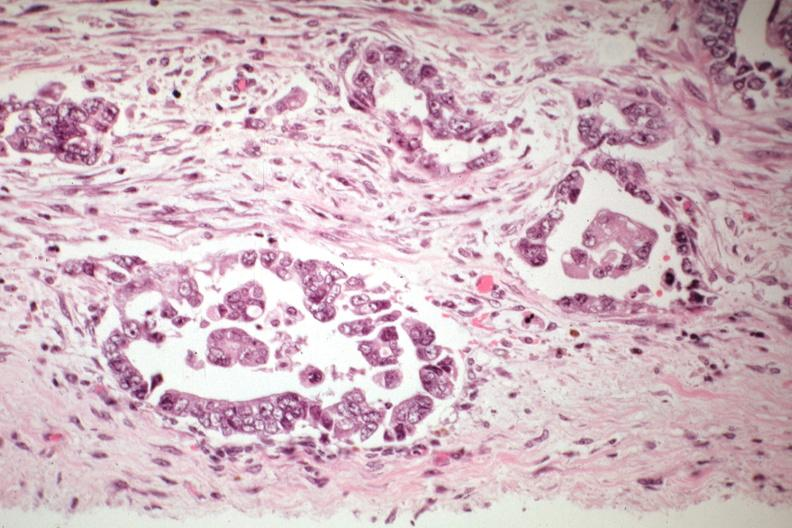s rocky mountain present?
Answer the question using a single word or phrase. No 